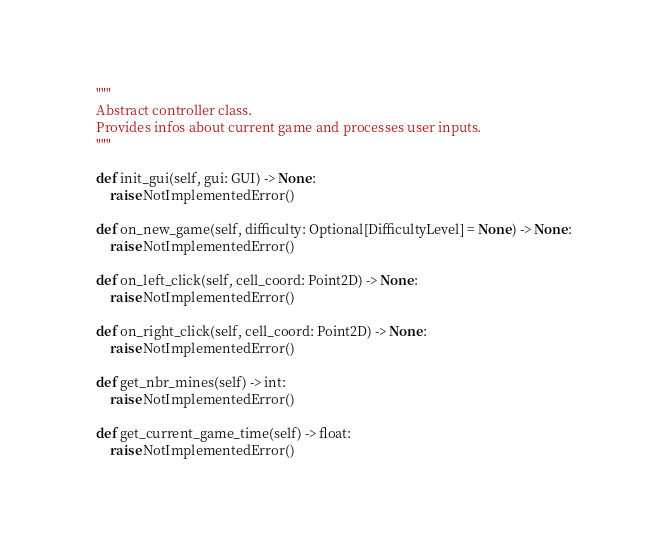<code> <loc_0><loc_0><loc_500><loc_500><_Python_>    """
    Abstract controller class.
    Provides infos about current game and processes user inputs.
    """

    def init_gui(self, gui: GUI) -> None:
        raise NotImplementedError()

    def on_new_game(self, difficulty: Optional[DifficultyLevel] = None) -> None:
        raise NotImplementedError()

    def on_left_click(self, cell_coord: Point2D) -> None:
        raise NotImplementedError()

    def on_right_click(self, cell_coord: Point2D) -> None:
        raise NotImplementedError()

    def get_nbr_mines(self) -> int:
        raise NotImplementedError()

    def get_current_game_time(self) -> float:
        raise NotImplementedError()
</code> 